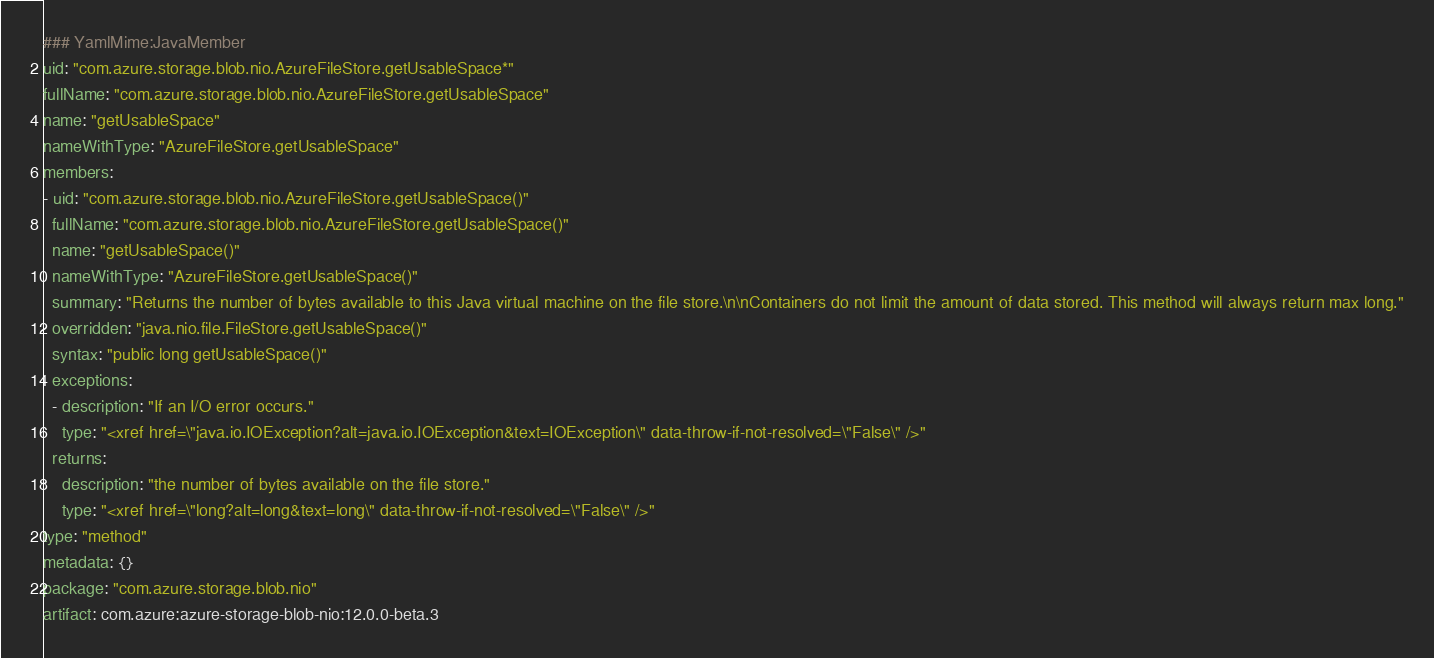<code> <loc_0><loc_0><loc_500><loc_500><_YAML_>### YamlMime:JavaMember
uid: "com.azure.storage.blob.nio.AzureFileStore.getUsableSpace*"
fullName: "com.azure.storage.blob.nio.AzureFileStore.getUsableSpace"
name: "getUsableSpace"
nameWithType: "AzureFileStore.getUsableSpace"
members:
- uid: "com.azure.storage.blob.nio.AzureFileStore.getUsableSpace()"
  fullName: "com.azure.storage.blob.nio.AzureFileStore.getUsableSpace()"
  name: "getUsableSpace()"
  nameWithType: "AzureFileStore.getUsableSpace()"
  summary: "Returns the number of bytes available to this Java virtual machine on the file store.\n\nContainers do not limit the amount of data stored. This method will always return max long."
  overridden: "java.nio.file.FileStore.getUsableSpace()"
  syntax: "public long getUsableSpace()"
  exceptions:
  - description: "If an I/O error occurs."
    type: "<xref href=\"java.io.IOException?alt=java.io.IOException&text=IOException\" data-throw-if-not-resolved=\"False\" />"
  returns:
    description: "the number of bytes available on the file store."
    type: "<xref href=\"long?alt=long&text=long\" data-throw-if-not-resolved=\"False\" />"
type: "method"
metadata: {}
package: "com.azure.storage.blob.nio"
artifact: com.azure:azure-storage-blob-nio:12.0.0-beta.3
</code> 